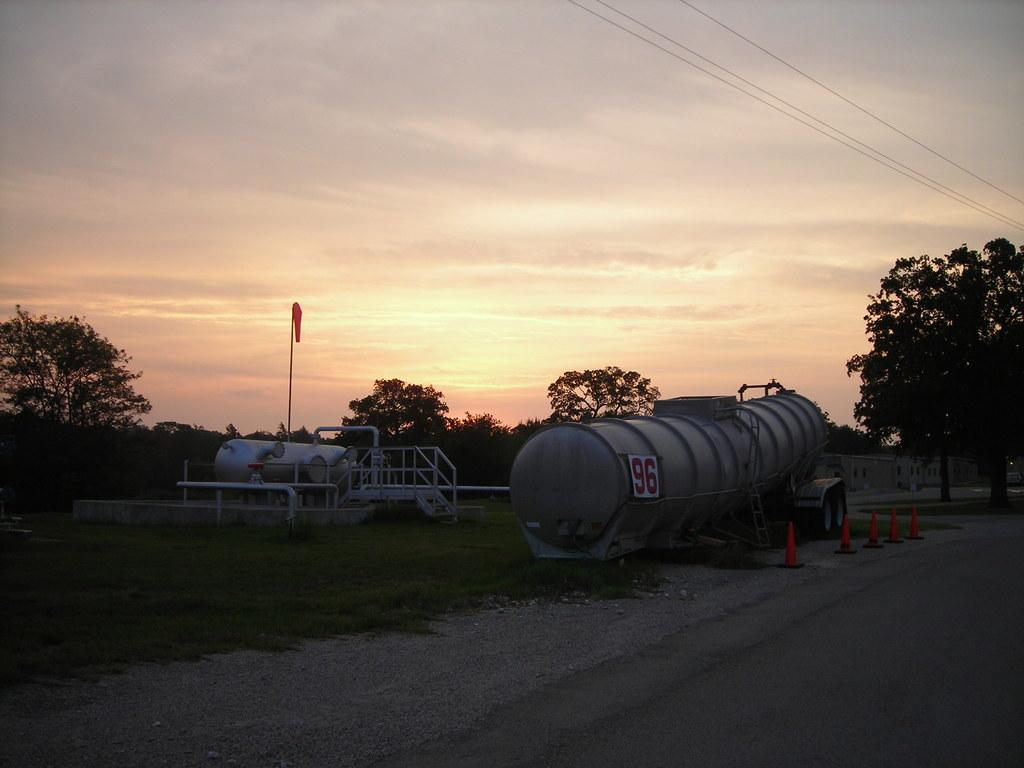What is the main feature of the image? There is a road in the image. What objects are placed on the road? Road cones are present in the image. What type of vegetation can be seen in the image? There is grass and trees in the image. What is visible in the background of the image? The sky in the background is dark, and clouds are visible. Can you describe the vehicle in the image? A vehicle is visible in the image. What else is present in the image? There is a flag and wires visible in the image. Can you hear the whistle of the birds flying in the image? There are no birds or whistling sounds present in the image. How does the person touch the clouds in the image? There is no person present in the image, and the clouds are in the background, so it is not possible to touch them. 